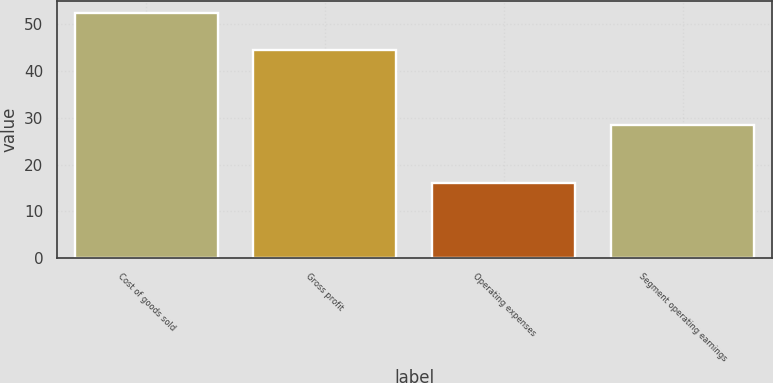<chart> <loc_0><loc_0><loc_500><loc_500><bar_chart><fcel>Cost of goods sold<fcel>Gross profit<fcel>Operating expenses<fcel>Segment operating earnings<nl><fcel>52.3<fcel>44.5<fcel>16<fcel>28.5<nl></chart> 